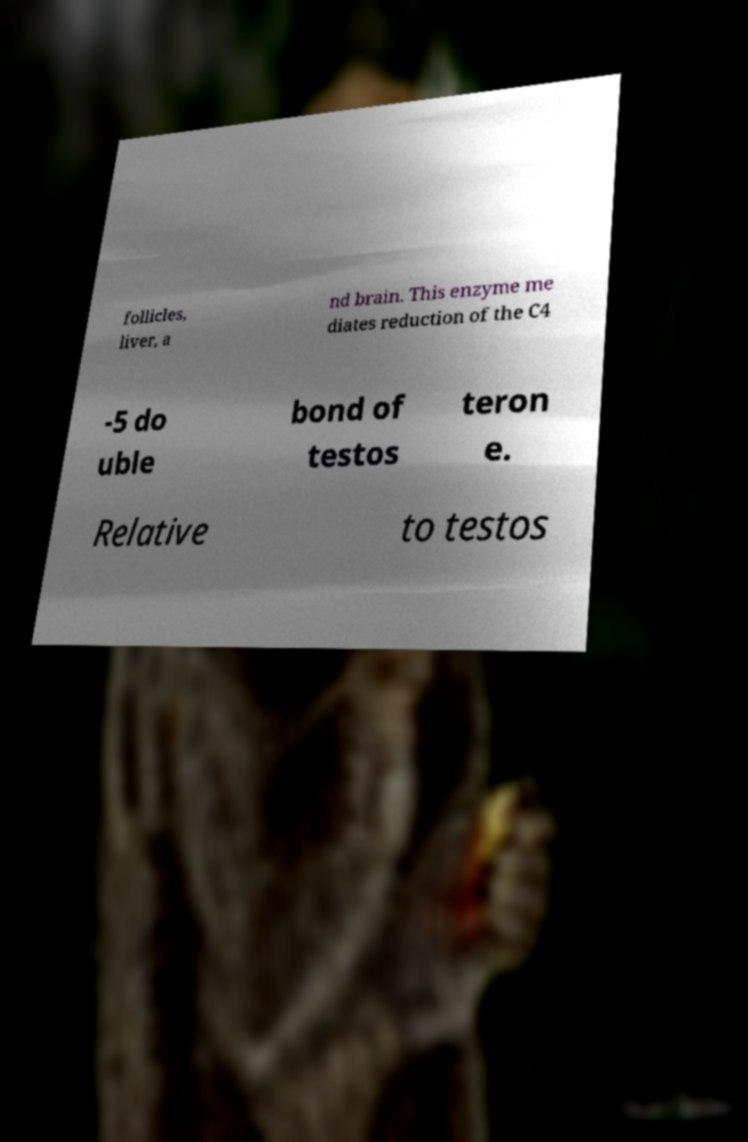For documentation purposes, I need the text within this image transcribed. Could you provide that? follicles, liver, a nd brain. This enzyme me diates reduction of the C4 -5 do uble bond of testos teron e. Relative to testos 